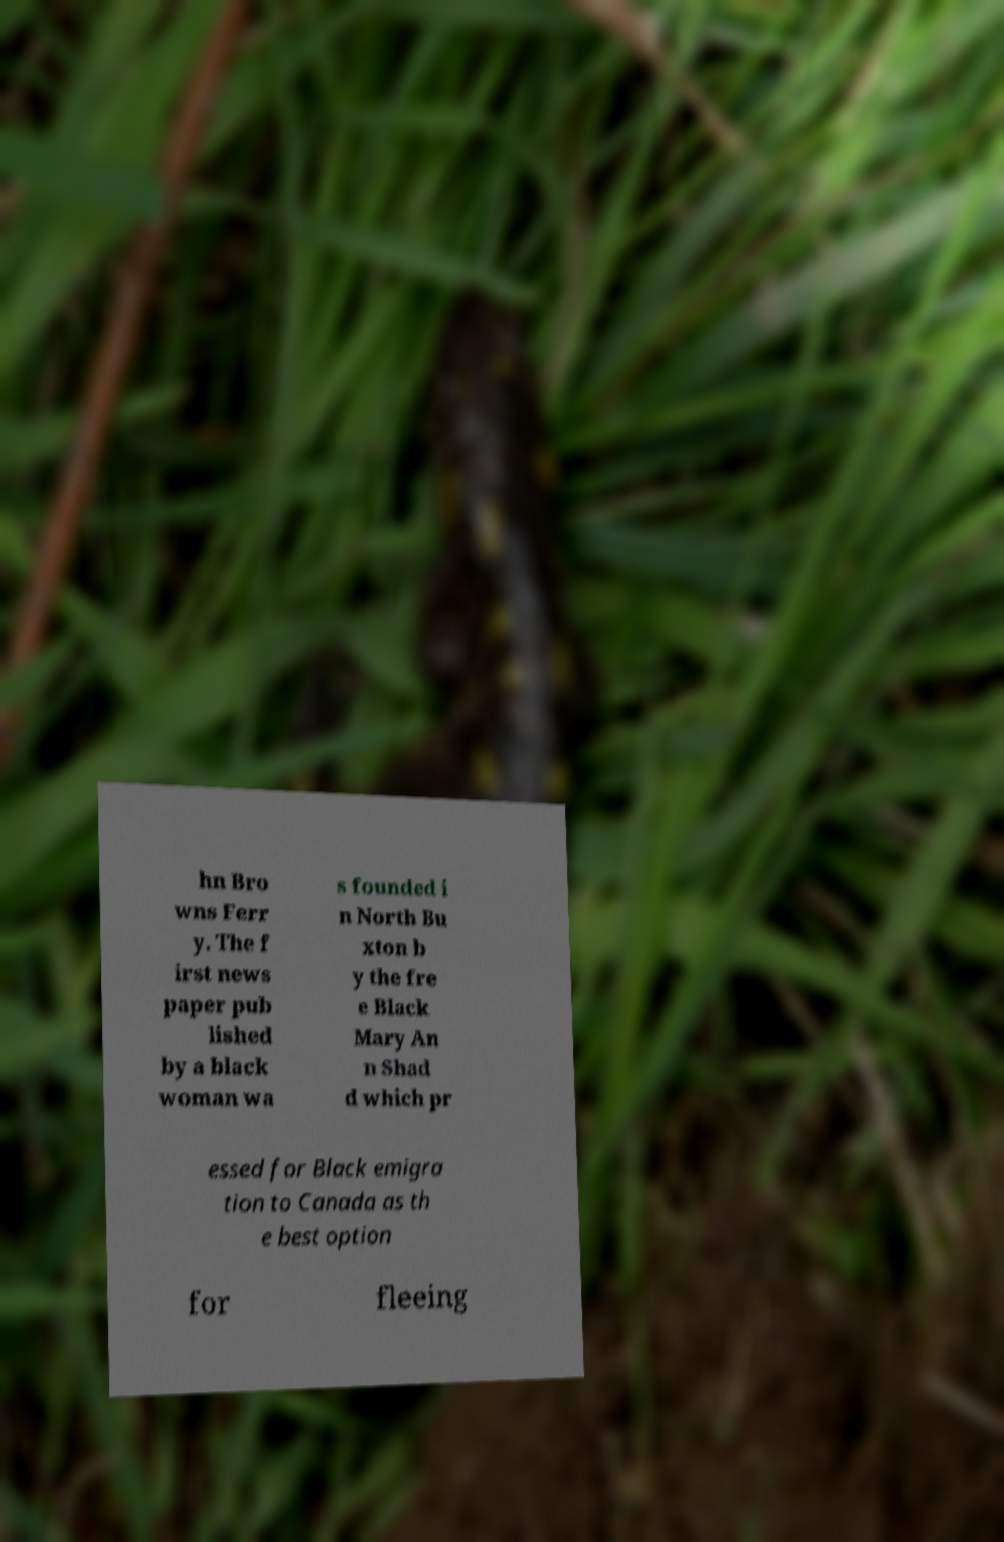I need the written content from this picture converted into text. Can you do that? hn Bro wns Ferr y. The f irst news paper pub lished by a black woman wa s founded i n North Bu xton b y the fre e Black Mary An n Shad d which pr essed for Black emigra tion to Canada as th e best option for fleeing 